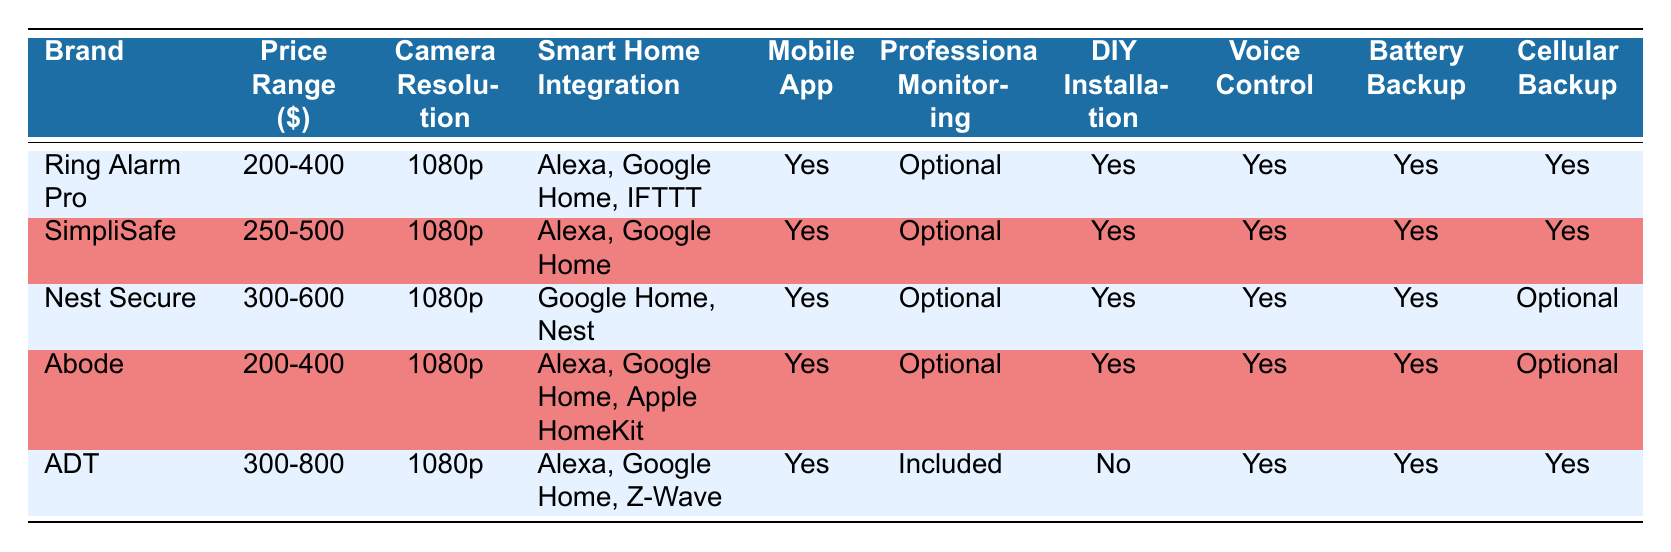What is the price range of the ADT security system? The table clearly lists the price range of the ADT security system in the "Price Range ($)" column, which shows "300-800".
Answer: 300-800 Which brands offer 1080p camera resolution? Looking at the "Camera Resolution" column in the table, all brands listed have "1080p" as their camera resolution.
Answer: All brands Is professional monitoring included in the SimpliSafe system? The table indicates that professional monitoring for SimpliSafe is "Optional", meaning it is not included as a standard feature.
Answer: No Which system has the highest price range, and what is that range? By examining the price ranges in the "Price Range ($)" column, ADT has the highest range at "300-800".
Answer: 300-800 How many brands provide cellular backup? In the "Cellular Backup" column, we can see that five brands are listed, and out of these, "Yes" is indicated for four brands (Ring Alarm Pro, SimpliSafe, ADT) and "Optional" for Nest Secure and Abode, resulting in a total of five brands providing cellular backup.
Answer: Five brands Which systems support Apple HomeKit integration? The "Smart Home Integration" column shows that "Abode" is the only brand that mentions integration with "Apple HomeKit".
Answer: Abode Are there any systems that do not require DIY installation? By checking the "DIY Installation" column, we find that only the ADT system does not support "DIY Installation," as it is shown as "No".
Answer: Yes, ADT What is the average price range of the systems listed? The price ranges provided are: 200-400, 250-500, 300-600, 200-400, and 300-800. Converting these ranges into their average values gives: (300 + 250 + 450 + 300 + 550) / 5 = 370. With two ranges (200-400 and 300-600) counted as 300 and 500 respectively, the overall average remains 370.
Answer: 370 